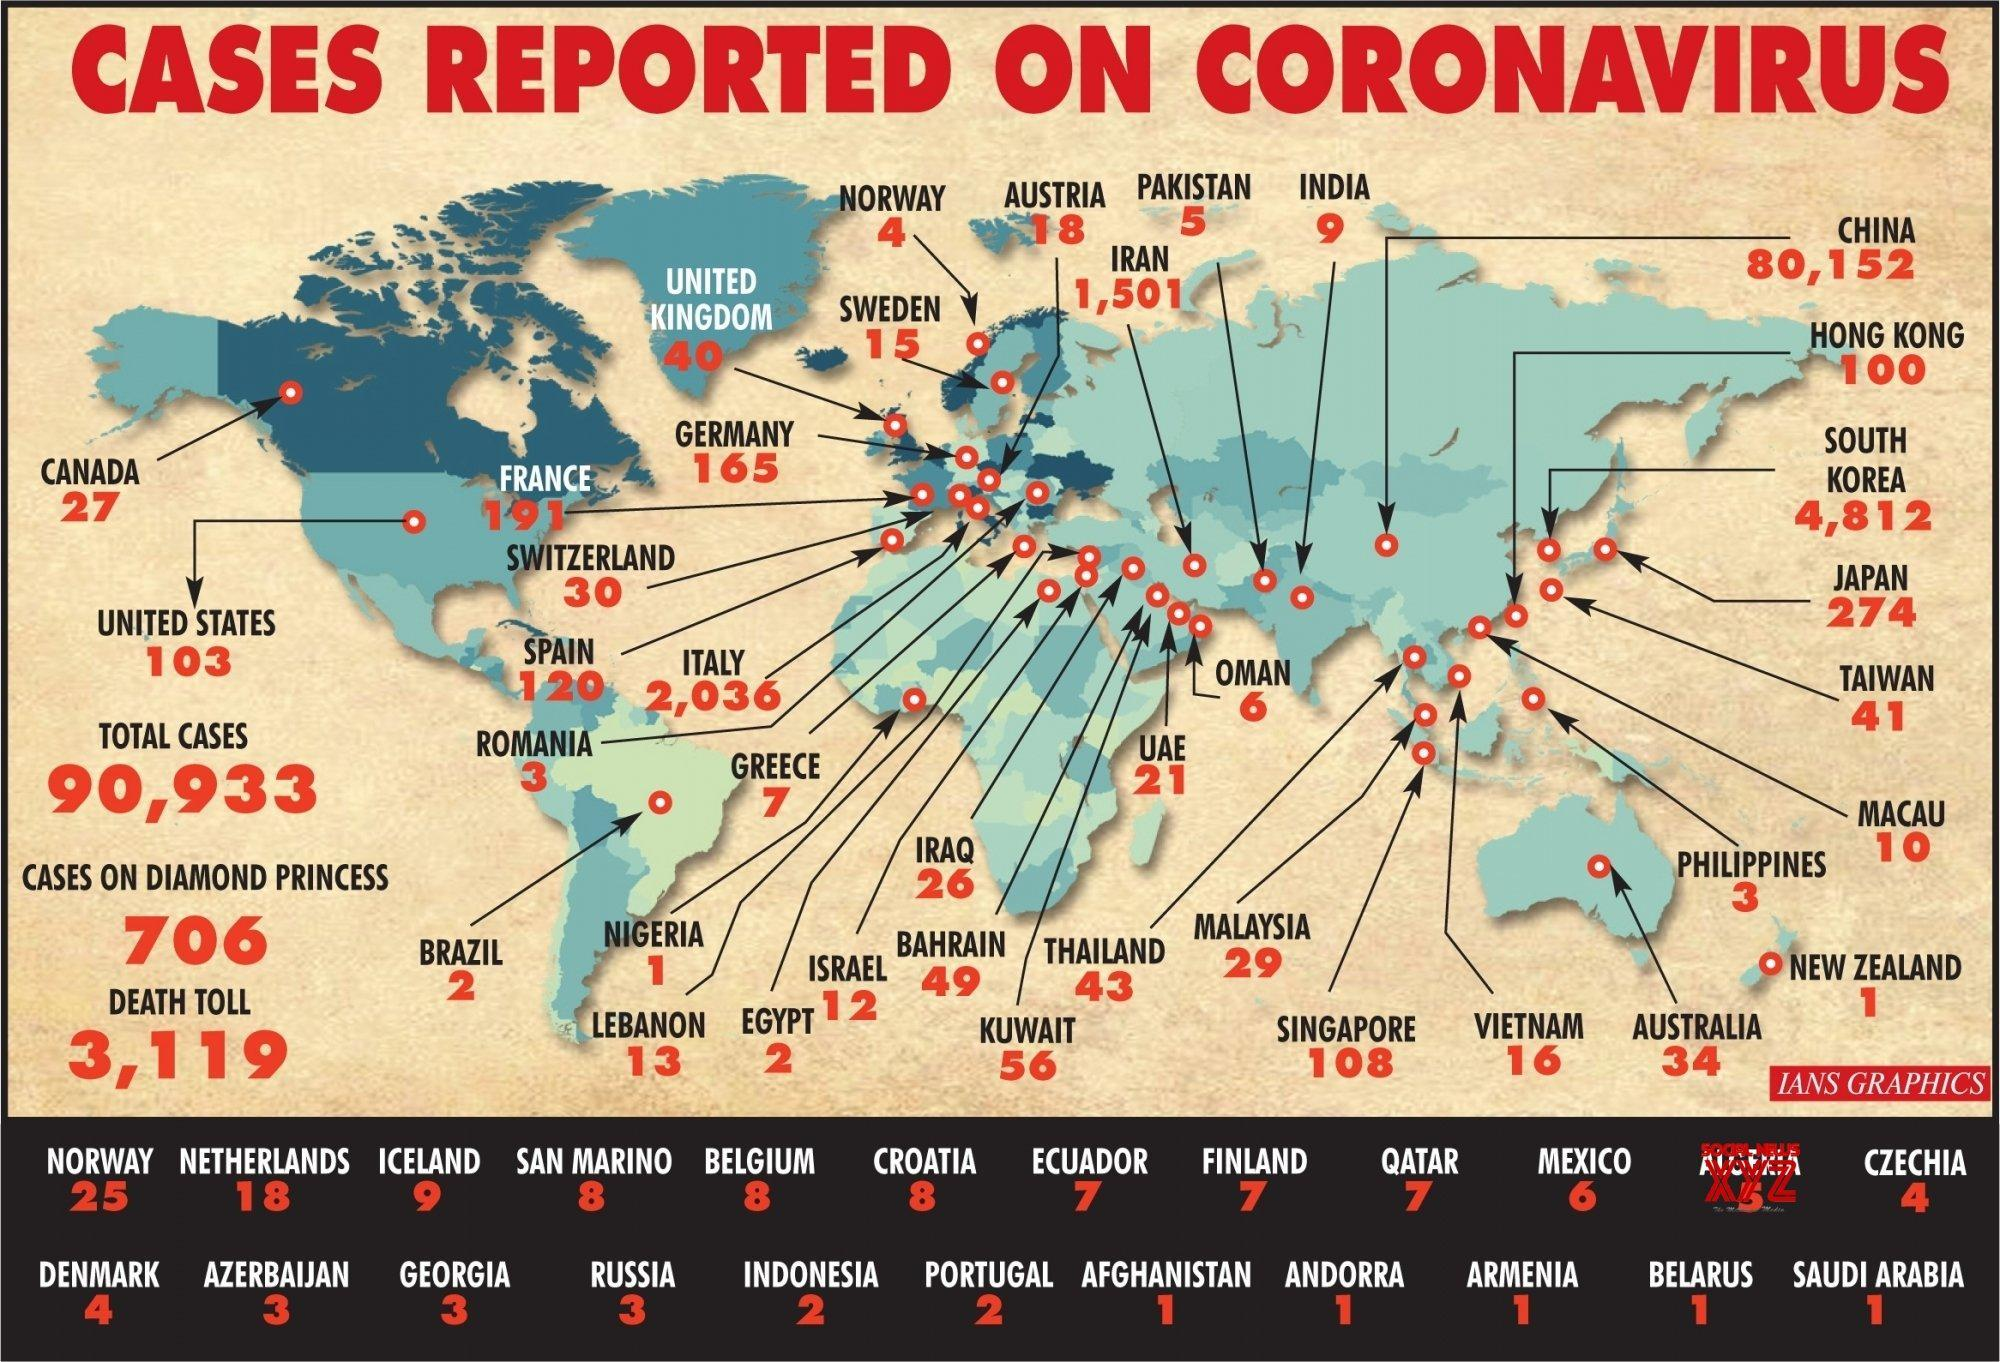Which country has reported the second highest number of COVID-19 cases globally?
Answer the question with a short phrase. SOUTH KOREA What is the number of COVID-19 cases reported in Australia? 34 What is the number of COVID-19 cases reported in Italy? 2,036 Which country has reported the third highest number of COVID-19 cases globally? ITALY What is the number of COVID-19 cases reported in Qatar? 7 What is the total number of COVID-19 deaths reported globally? 3,119 Which country has reported the highest number of COVID-19 cases globally? CHINA 